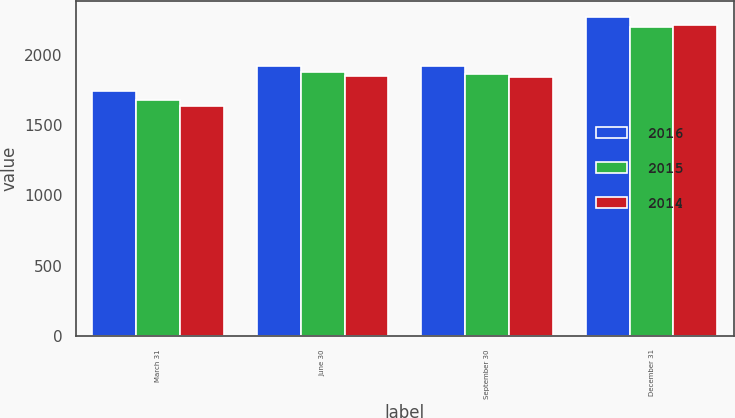Convert chart to OTSL. <chart><loc_0><loc_0><loc_500><loc_500><stacked_bar_chart><ecel><fcel>March 31<fcel>June 30<fcel>September 30<fcel>December 31<nl><fcel>2016<fcel>1742<fcel>1917.9<fcel>1922.2<fcel>2264.5<nl><fcel>2015<fcel>1676<fcel>1876.1<fcel>1865.5<fcel>2196.2<nl><fcel>2014<fcel>1637.5<fcel>1851.4<fcel>1841.1<fcel>2207.1<nl></chart> 